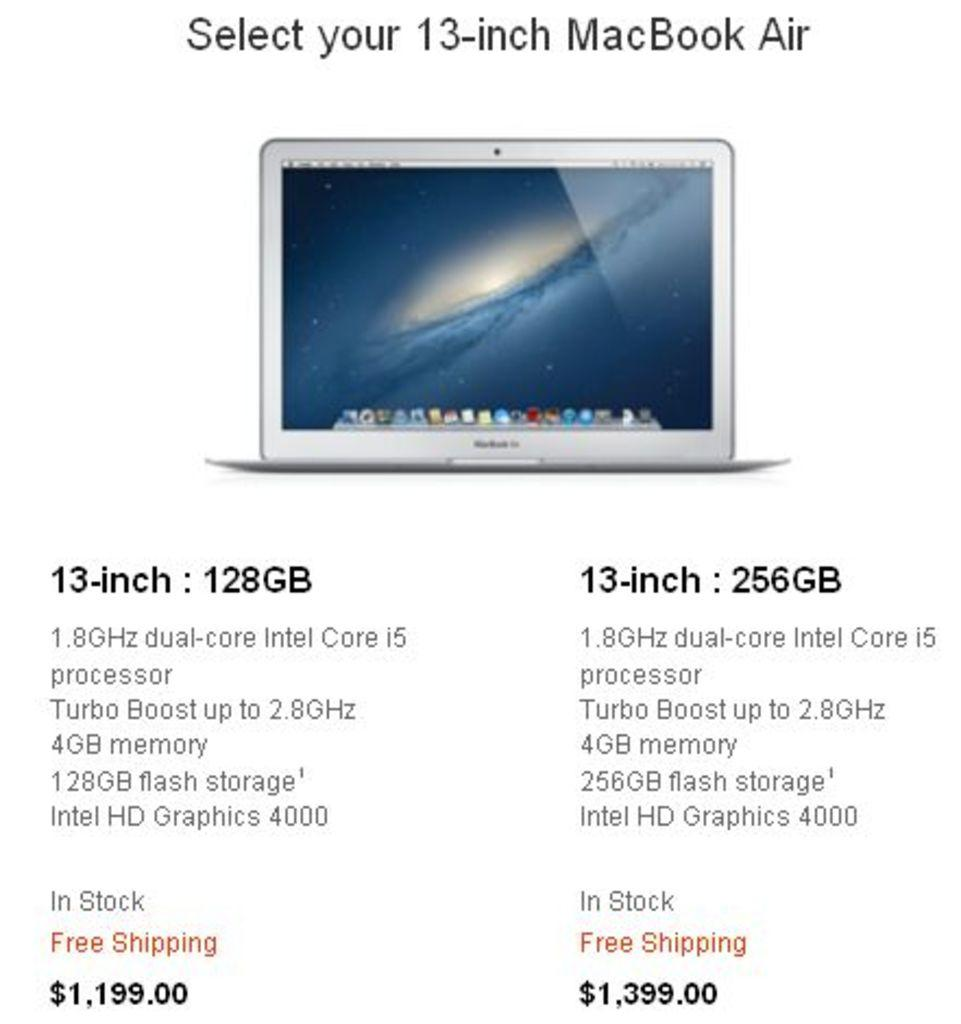<image>
Present a compact description of the photo's key features. Details regarding a 13-inch MacBook Air which includes 4gb memory 